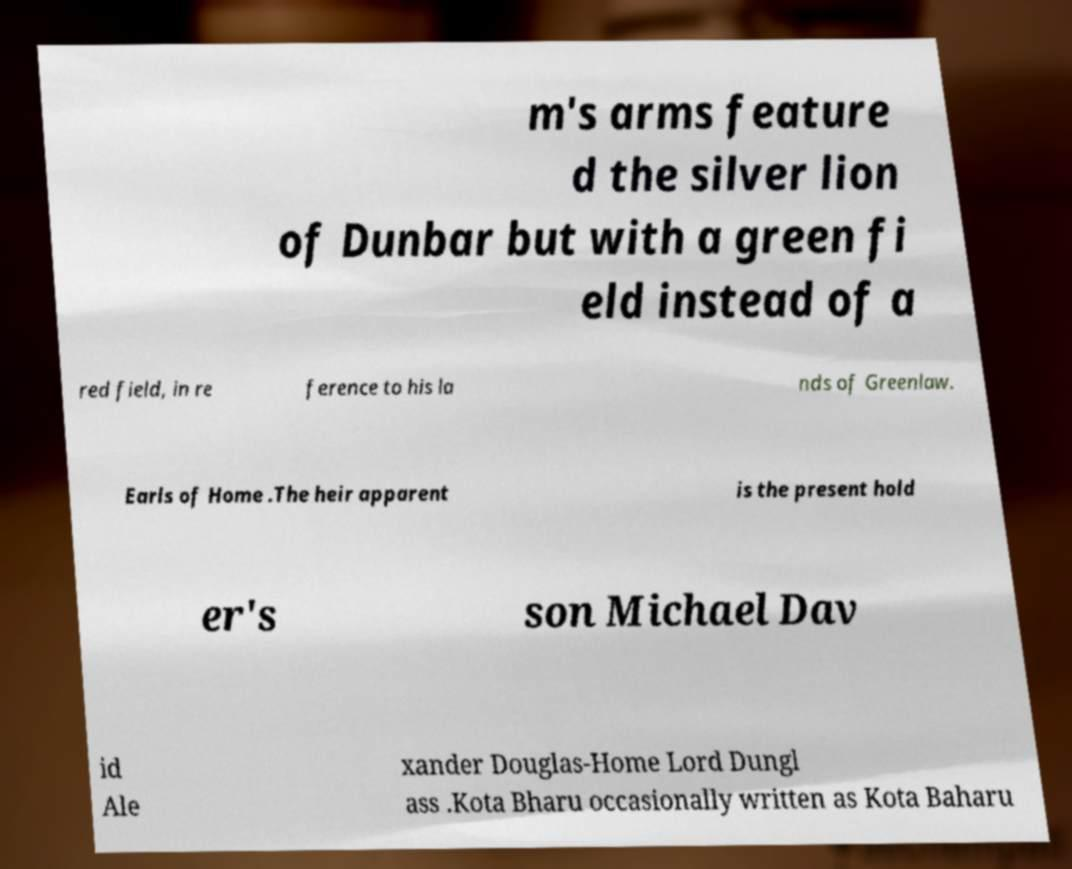Can you accurately transcribe the text from the provided image for me? m's arms feature d the silver lion of Dunbar but with a green fi eld instead of a red field, in re ference to his la nds of Greenlaw. Earls of Home .The heir apparent is the present hold er's son Michael Dav id Ale xander Douglas-Home Lord Dungl ass .Kota Bharu occasionally written as Kota Baharu 